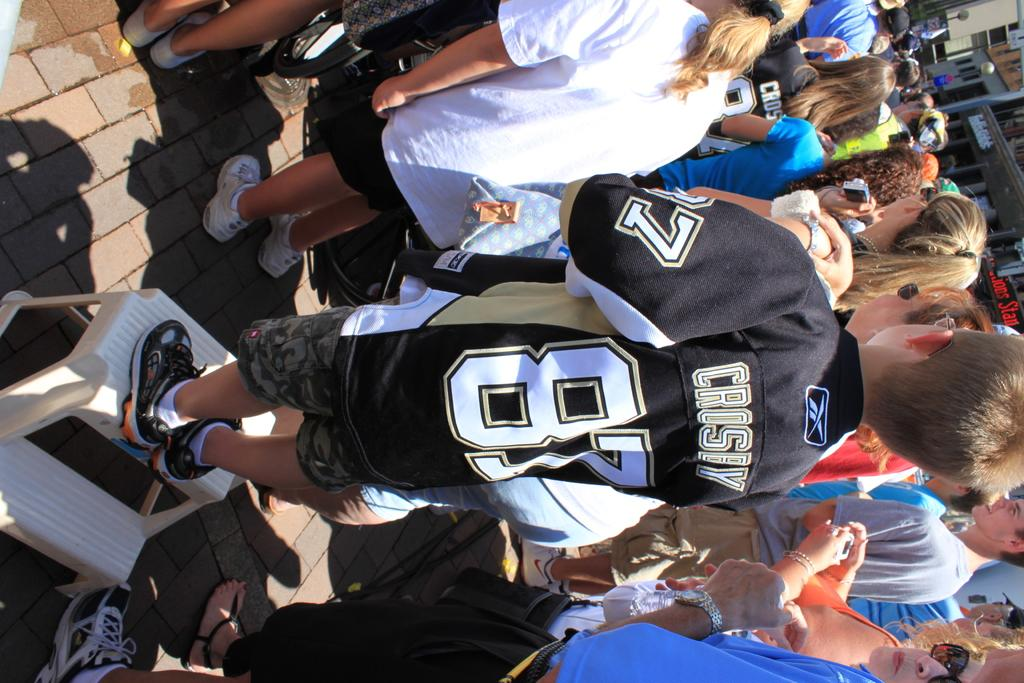<image>
Present a compact description of the photo's key features. Person standing in a crowd wearing a number 87 jersey. 